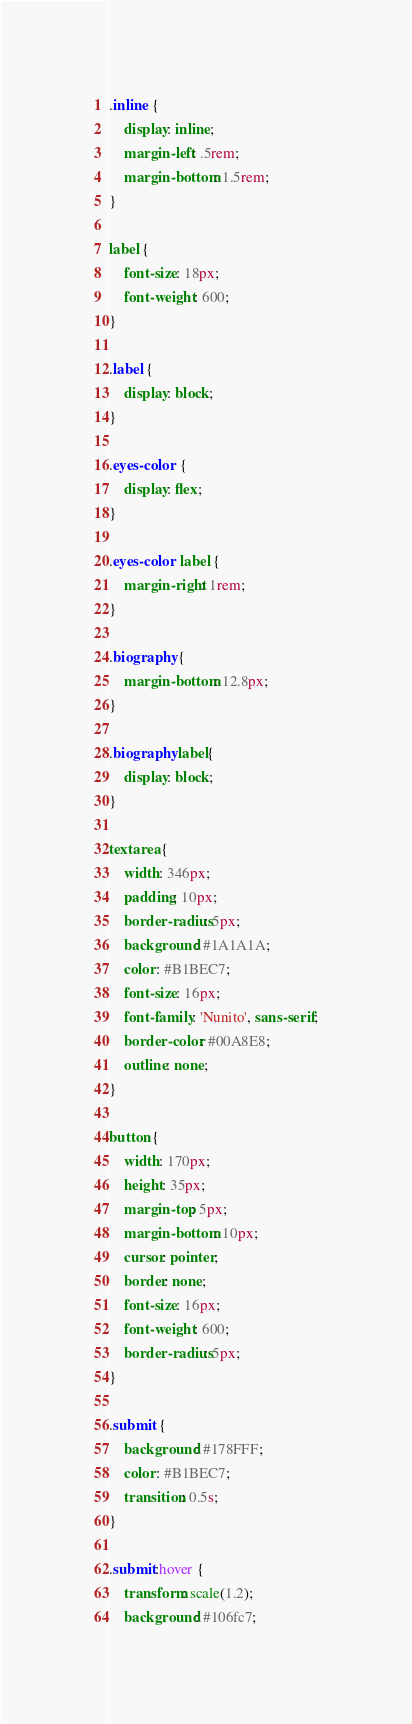Convert code to text. <code><loc_0><loc_0><loc_500><loc_500><_CSS_>
.inline {
    display: inline;
    margin-left: .5rem;
    margin-bottom: 1.5rem;
}

label {
    font-size: 18px;
    font-weight: 600;
}

.label {
    display: block;
}

.eyes-color {
    display: flex;   
}

.eyes-color label {
    margin-right: 1rem;
}

.biography {
    margin-bottom: 12.8px;
}

.biography label{
    display: block;
}

textarea {
    width: 346px;
    padding: 10px;
    border-radius: 5px;
    background: #1A1A1A;
    color: #B1BEC7;
    font-size: 16px;
    font-family: 'Nunito', sans-serif;
    border-color: #00A8E8;
    outline: none;
}

button {
    width: 170px;
    height: 35px;
    margin-top: 5px;
    margin-bottom: 10px;
    cursor: pointer;
    border: none;
    font-size: 16px;
    font-weight: 600;
    border-radius: 5px;
}

.submit {
    background: #178FFF;  
    color: #B1BEC7;
    transition: 0.5s;
}

.submit:hover {
    transform: scale(1.2);
    background: #106fc7;</code> 